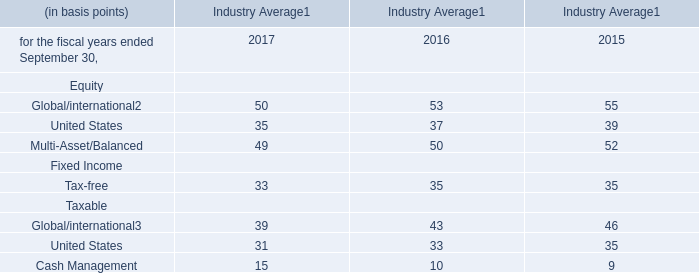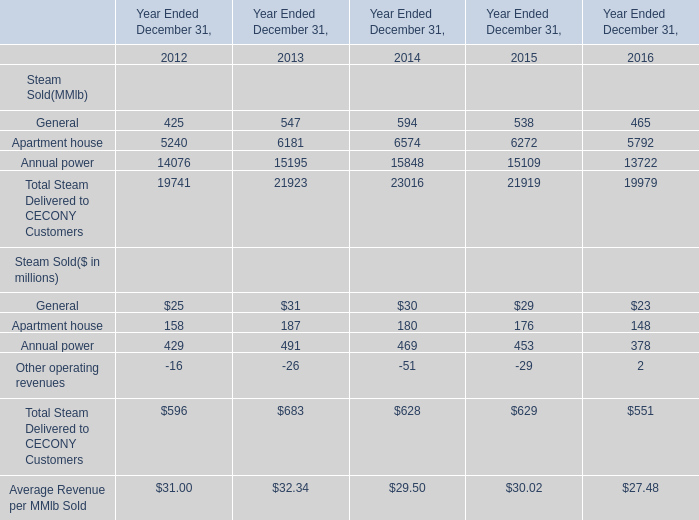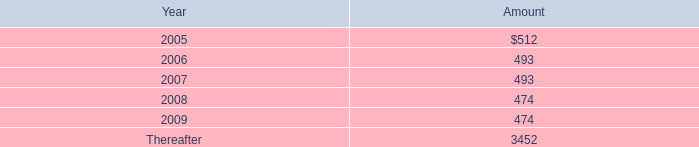what is the percentual increase expense related to these plans during 2002 and 2003? 
Computations: ((4197 / 2728) - 1)
Answer: 0.53849. 